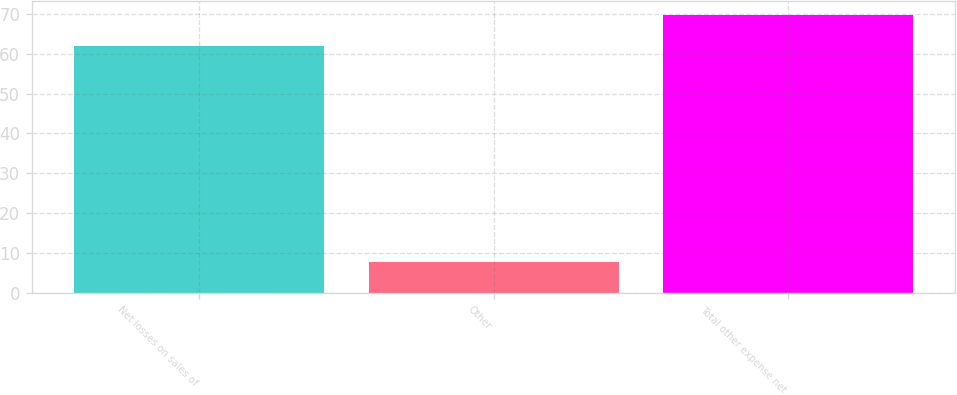Convert chart to OTSL. <chart><loc_0><loc_0><loc_500><loc_500><bar_chart><fcel>Net losses on sales of<fcel>Other<fcel>Total other expense net<nl><fcel>61.9<fcel>7.7<fcel>69.6<nl></chart> 